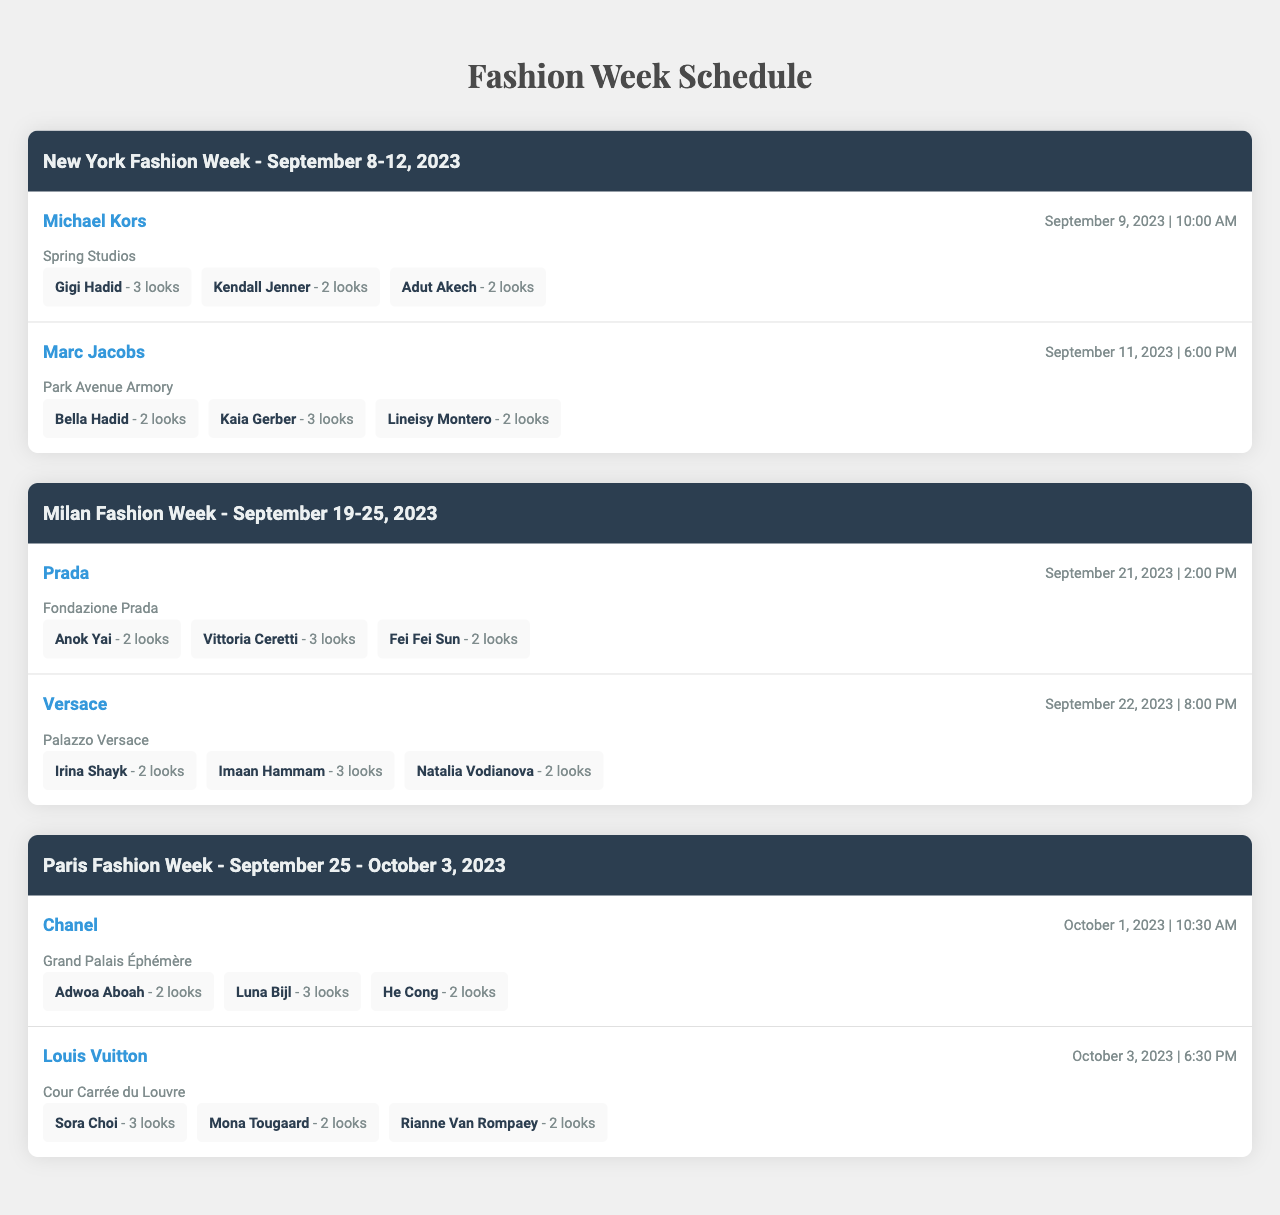What is the date of the New York Fashion Week? The table indicates that the New York Fashion Week is from September 8-12, 2023.
Answer: September 8-12, 2023 How many looks did Gigi Hadid present during Michael Kors' show? The table lists Gigi Hadid as having 3 looks during the Michael Kors show.
Answer: 3 Which designer's show takes place last during Paris Fashion Week? According to the table, Louis Vuitton's show is on October 3, 2023, and it is the last show listed for Paris Fashion Week.
Answer: Louis Vuitton What is the total number of looks presented by models in the Prada show? The table lists 3 models presenting looks in the Prada show: Anok Yai with 2 looks, Vittoria Ceretti with 3 looks, and Fei Fei Sun with 2 looks. The total is 2 + 3 + 2 = 7.
Answer: 7 Did Bella Hadid present more looks than Adut Akech? Bella Hadid has 2 looks in the Marc Jacobs show, while Adut Akech has 2 looks in the Michael Kors show, making the statement false as they are equal.
Answer: No Which model presented the highest number of looks overall? Analyzing the provided data, Kaia Gerber has 3 looks in the Marc Jacobs show, as does Vittoria Ceretti in the Prada show, but we need to compare all: Sora Choi also has 3 looks in the Louis Vuitton show, reaching three top models.
Answer: Kaia Gerber, Vittoria Ceretti, Sora Choi How many different locations are mentioned in the shows? The table lists three different locations: Spring Studios, Park Avenue Armory, Fondazione Prada, Palazzo Versace, Grand Palais Éphémère, and Cour Carrée du Louvre, totaling 6 unique locations.
Answer: 6 Which fashion week has the most shows listed? The table shows 2 shows for New York Fashion Week, 2 for Milan Fashion Week, and 2 for Paris Fashion Week. Therefore, all fashion weeks have the same number of shows, which is 2.
Answer: All have the same number of shows What is the average number of looks presented by each model in the Milan Fashion Week? In Milan, there are 6 looks presented by 6 models (Anok Yai 2 + Vittoria Ceretti 3 + Fei Fei Sun 2 + Irina Shayk 2 + Imaan Hammam 3 + Natalia Vodianova 2), which sums to 14 looks. Dividing 14 by 6 gives an average of 14 / 6 = 2.33.
Answer: 2.33 Which day is the Chanel show scheduled? The table indicates that the Chanel show is scheduled for October 1, 2023.
Answer: October 1, 2023 